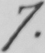What does this handwritten line say? 7 . 